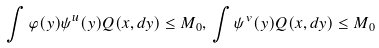<formula> <loc_0><loc_0><loc_500><loc_500>\int \varphi ( y ) \psi ^ { u } ( y ) Q ( x , d y ) \leq M _ { 0 } , \, \int \psi ^ { v } ( y ) Q ( x , d y ) \leq M _ { 0 }</formula> 